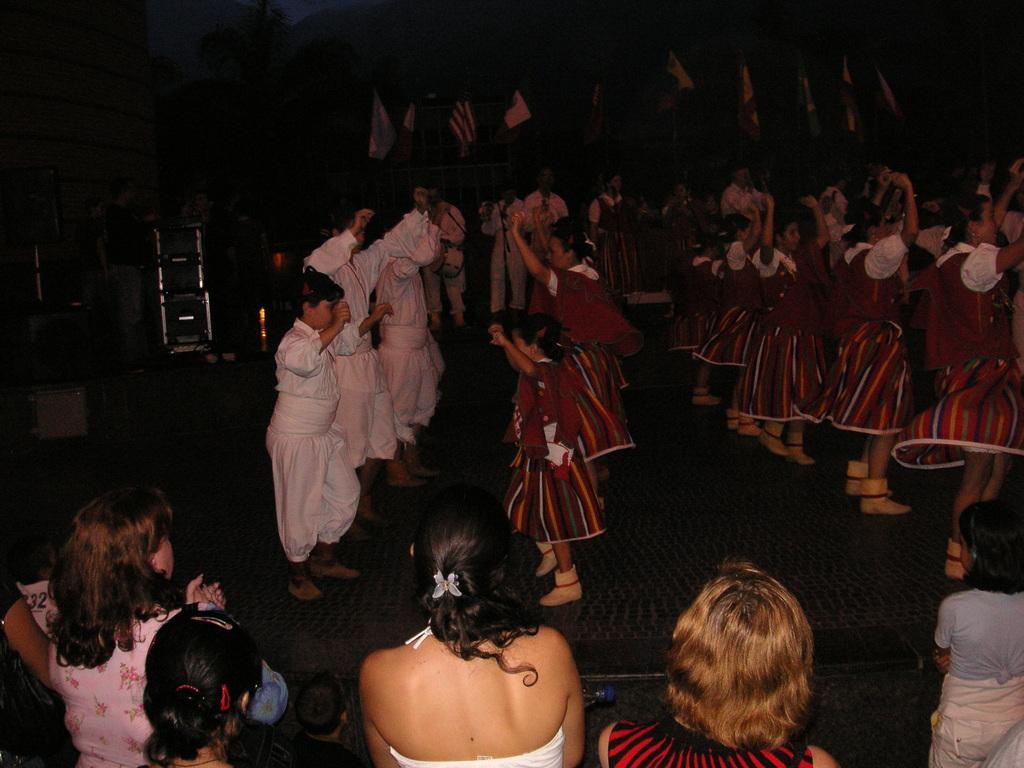How would you summarize this image in a sentence or two? This is an image clicked in the dark. In the middle of the image I can see few people wearing costumes and dancing on the floor. At the bottom of the image I can see some more people are looking at the people who are dancing. The background is in black color. 